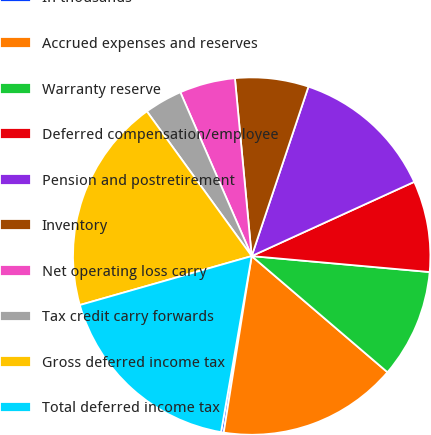Convert chart to OTSL. <chart><loc_0><loc_0><loc_500><loc_500><pie_chart><fcel>In thousands<fcel>Accrued expenses and reserves<fcel>Warranty reserve<fcel>Deferred compensation/employee<fcel>Pension and postretirement<fcel>Inventory<fcel>Net operating loss carry<fcel>Tax credit carry forwards<fcel>Gross deferred income tax<fcel>Total deferred income tax<nl><fcel>0.24%<fcel>16.24%<fcel>9.84%<fcel>8.24%<fcel>13.04%<fcel>6.64%<fcel>5.04%<fcel>3.44%<fcel>19.44%<fcel>17.84%<nl></chart> 